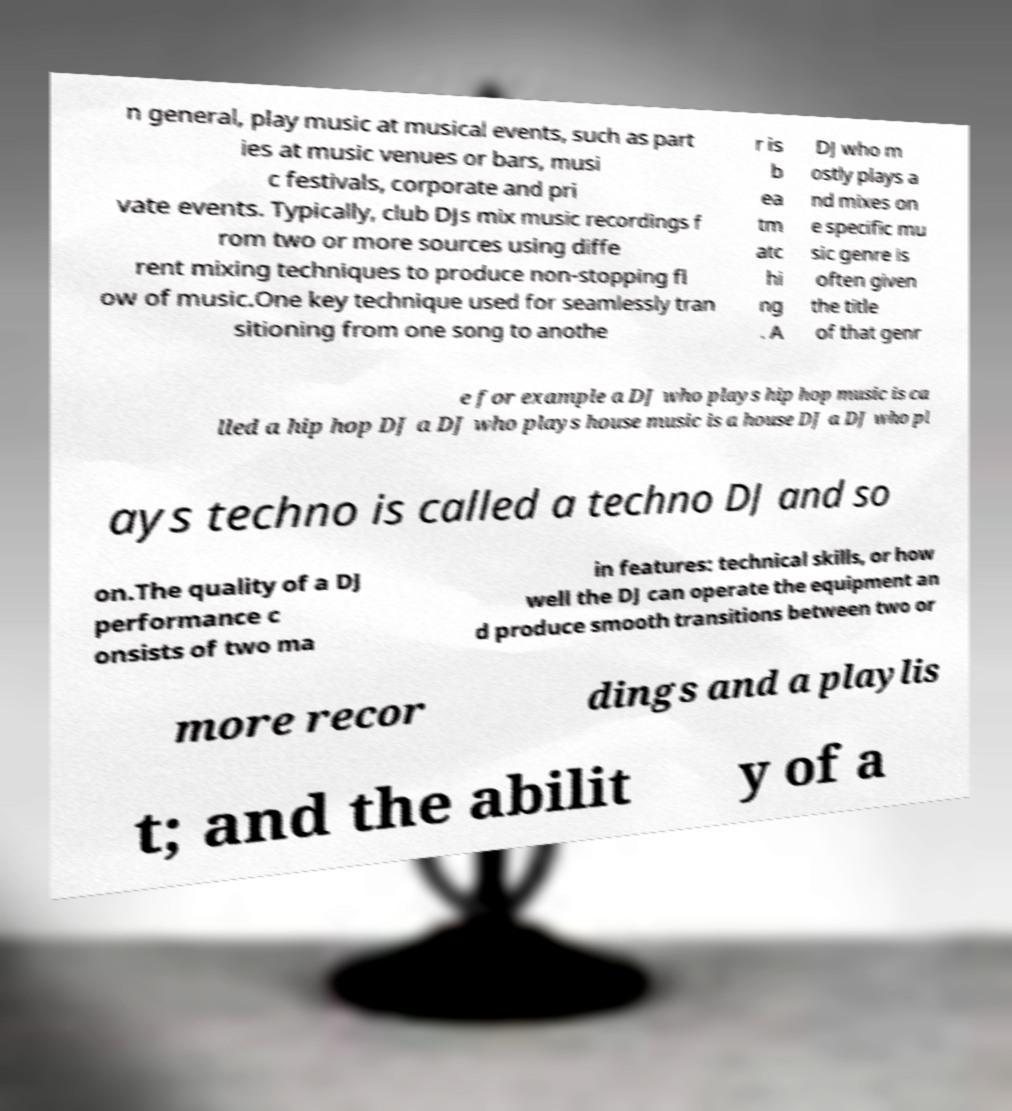Could you extract and type out the text from this image? n general, play music at musical events, such as part ies at music venues or bars, musi c festivals, corporate and pri vate events. Typically, club DJs mix music recordings f rom two or more sources using diffe rent mixing techniques to produce non-stopping fl ow of music.One key technique used for seamlessly tran sitioning from one song to anothe r is b ea tm atc hi ng . A DJ who m ostly plays a nd mixes on e specific mu sic genre is often given the title of that genr e for example a DJ who plays hip hop music is ca lled a hip hop DJ a DJ who plays house music is a house DJ a DJ who pl ays techno is called a techno DJ and so on.The quality of a DJ performance c onsists of two ma in features: technical skills, or how well the DJ can operate the equipment an d produce smooth transitions between two or more recor dings and a playlis t; and the abilit y of a 